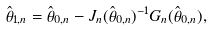Convert formula to latex. <formula><loc_0><loc_0><loc_500><loc_500>\hat { \theta } _ { 1 , n } = \hat { \theta } _ { 0 , n } - J _ { n } ( \hat { \theta } _ { 0 , n } ) ^ { - 1 } G _ { n } ( \hat { \theta } _ { 0 , n } ) ,</formula> 